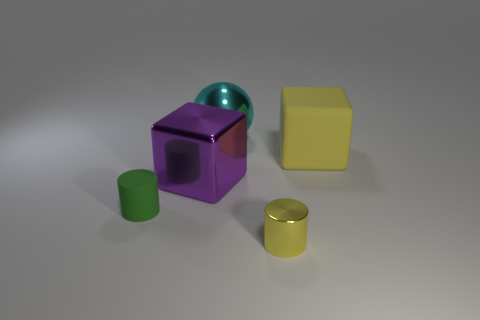Subtract all spheres. How many objects are left? 4 Add 1 purple things. How many objects exist? 6 Subtract 0 cyan cylinders. How many objects are left? 5 Subtract all large green rubber blocks. Subtract all matte things. How many objects are left? 3 Add 5 large shiny objects. How many large shiny objects are left? 7 Add 2 big yellow blocks. How many big yellow blocks exist? 3 